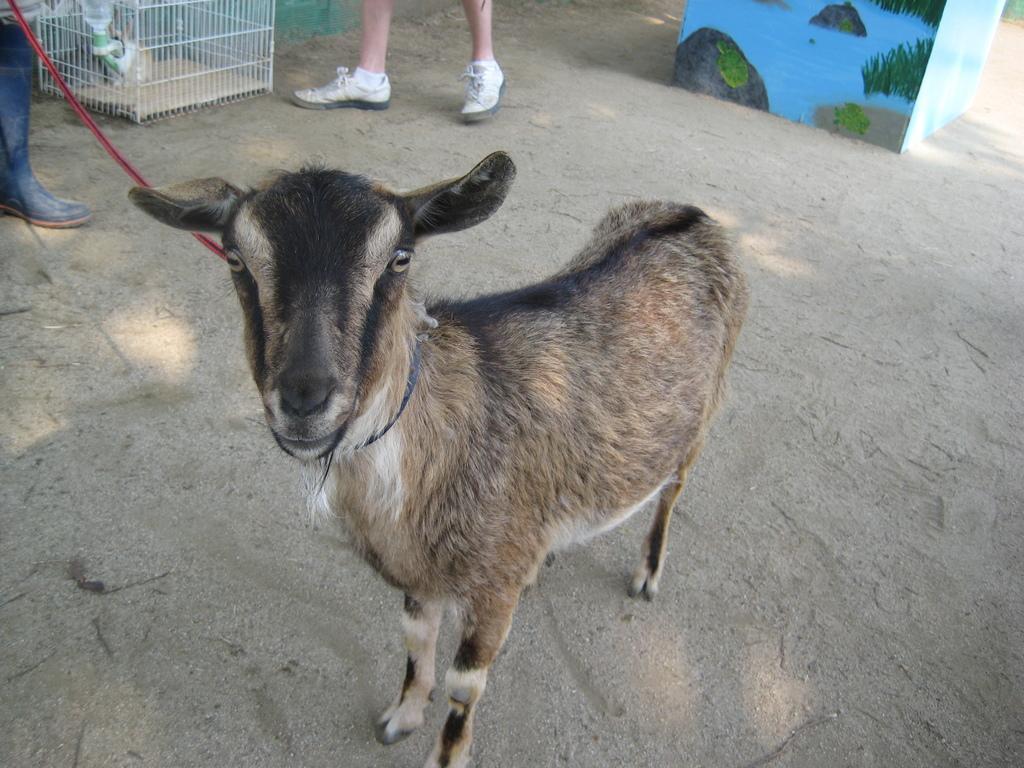In one or two sentences, can you explain what this image depicts? This image is taken outdoors. At the bottom of the image there is a ground. In the background there is a cage. There is a person walking on the ground. There is an object which is in a cube shape. On the left side of the image there is a person standing on the ground. In the middle of the image there is a goat. 